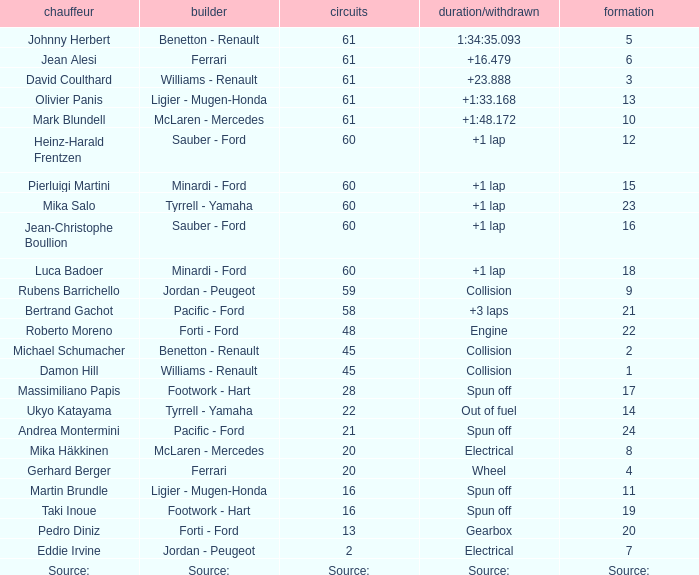How many laps does luca badoer have? 60.0. 